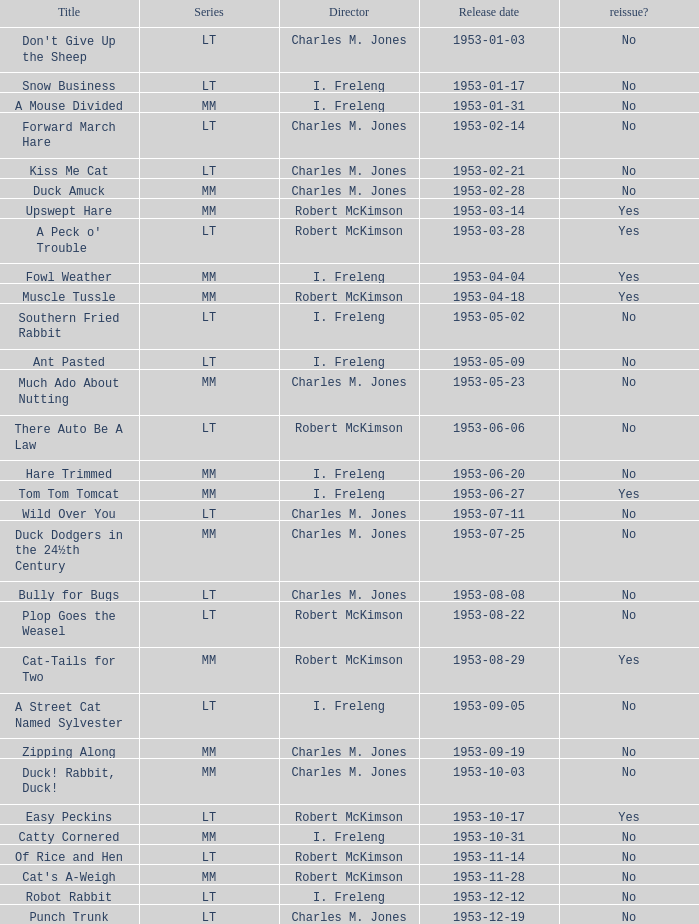I'm looking to parse the entire table for insights. Could you assist me with that? {'header': ['Title', 'Series', 'Director', 'Release date', 'reissue?'], 'rows': [["Don't Give Up the Sheep", 'LT', 'Charles M. Jones', '1953-01-03', 'No'], ['Snow Business', 'LT', 'I. Freleng', '1953-01-17', 'No'], ['A Mouse Divided', 'MM', 'I. Freleng', '1953-01-31', 'No'], ['Forward March Hare', 'LT', 'Charles M. Jones', '1953-02-14', 'No'], ['Kiss Me Cat', 'LT', 'Charles M. Jones', '1953-02-21', 'No'], ['Duck Amuck', 'MM', 'Charles M. Jones', '1953-02-28', 'No'], ['Upswept Hare', 'MM', 'Robert McKimson', '1953-03-14', 'Yes'], ["A Peck o' Trouble", 'LT', 'Robert McKimson', '1953-03-28', 'Yes'], ['Fowl Weather', 'MM', 'I. Freleng', '1953-04-04', 'Yes'], ['Muscle Tussle', 'MM', 'Robert McKimson', '1953-04-18', 'Yes'], ['Southern Fried Rabbit', 'LT', 'I. Freleng', '1953-05-02', 'No'], ['Ant Pasted', 'LT', 'I. Freleng', '1953-05-09', 'No'], ['Much Ado About Nutting', 'MM', 'Charles M. Jones', '1953-05-23', 'No'], ['There Auto Be A Law', 'LT', 'Robert McKimson', '1953-06-06', 'No'], ['Hare Trimmed', 'MM', 'I. Freleng', '1953-06-20', 'No'], ['Tom Tom Tomcat', 'MM', 'I. Freleng', '1953-06-27', 'Yes'], ['Wild Over You', 'LT', 'Charles M. Jones', '1953-07-11', 'No'], ['Duck Dodgers in the 24½th Century', 'MM', 'Charles M. Jones', '1953-07-25', 'No'], ['Bully for Bugs', 'LT', 'Charles M. Jones', '1953-08-08', 'No'], ['Plop Goes the Weasel', 'LT', 'Robert McKimson', '1953-08-22', 'No'], ['Cat-Tails for Two', 'MM', 'Robert McKimson', '1953-08-29', 'Yes'], ['A Street Cat Named Sylvester', 'LT', 'I. Freleng', '1953-09-05', 'No'], ['Zipping Along', 'MM', 'Charles M. Jones', '1953-09-19', 'No'], ['Duck! Rabbit, Duck!', 'MM', 'Charles M. Jones', '1953-10-03', 'No'], ['Easy Peckins', 'LT', 'Robert McKimson', '1953-10-17', 'Yes'], ['Catty Cornered', 'MM', 'I. Freleng', '1953-10-31', 'No'], ['Of Rice and Hen', 'LT', 'Robert McKimson', '1953-11-14', 'No'], ["Cat's A-Weigh", 'MM', 'Robert McKimson', '1953-11-28', 'No'], ['Robot Rabbit', 'LT', 'I. Freleng', '1953-12-12', 'No'], ['Punch Trunk', 'LT', 'Charles M. Jones', '1953-12-19', 'No']]} What's the release date of Forward March Hare? 1953-02-14. 